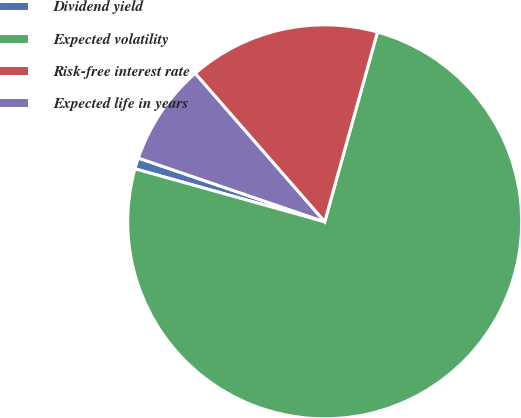Convert chart. <chart><loc_0><loc_0><loc_500><loc_500><pie_chart><fcel>Dividend yield<fcel>Expected volatility<fcel>Risk-free interest rate<fcel>Expected life in years<nl><fcel>0.91%<fcel>75.02%<fcel>15.74%<fcel>8.33%<nl></chart> 